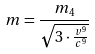Convert formula to latex. <formula><loc_0><loc_0><loc_500><loc_500>m = \frac { m _ { 4 } } { \sqrt { 3 \cdot \frac { v ^ { 9 } } { c ^ { 9 } } } }</formula> 